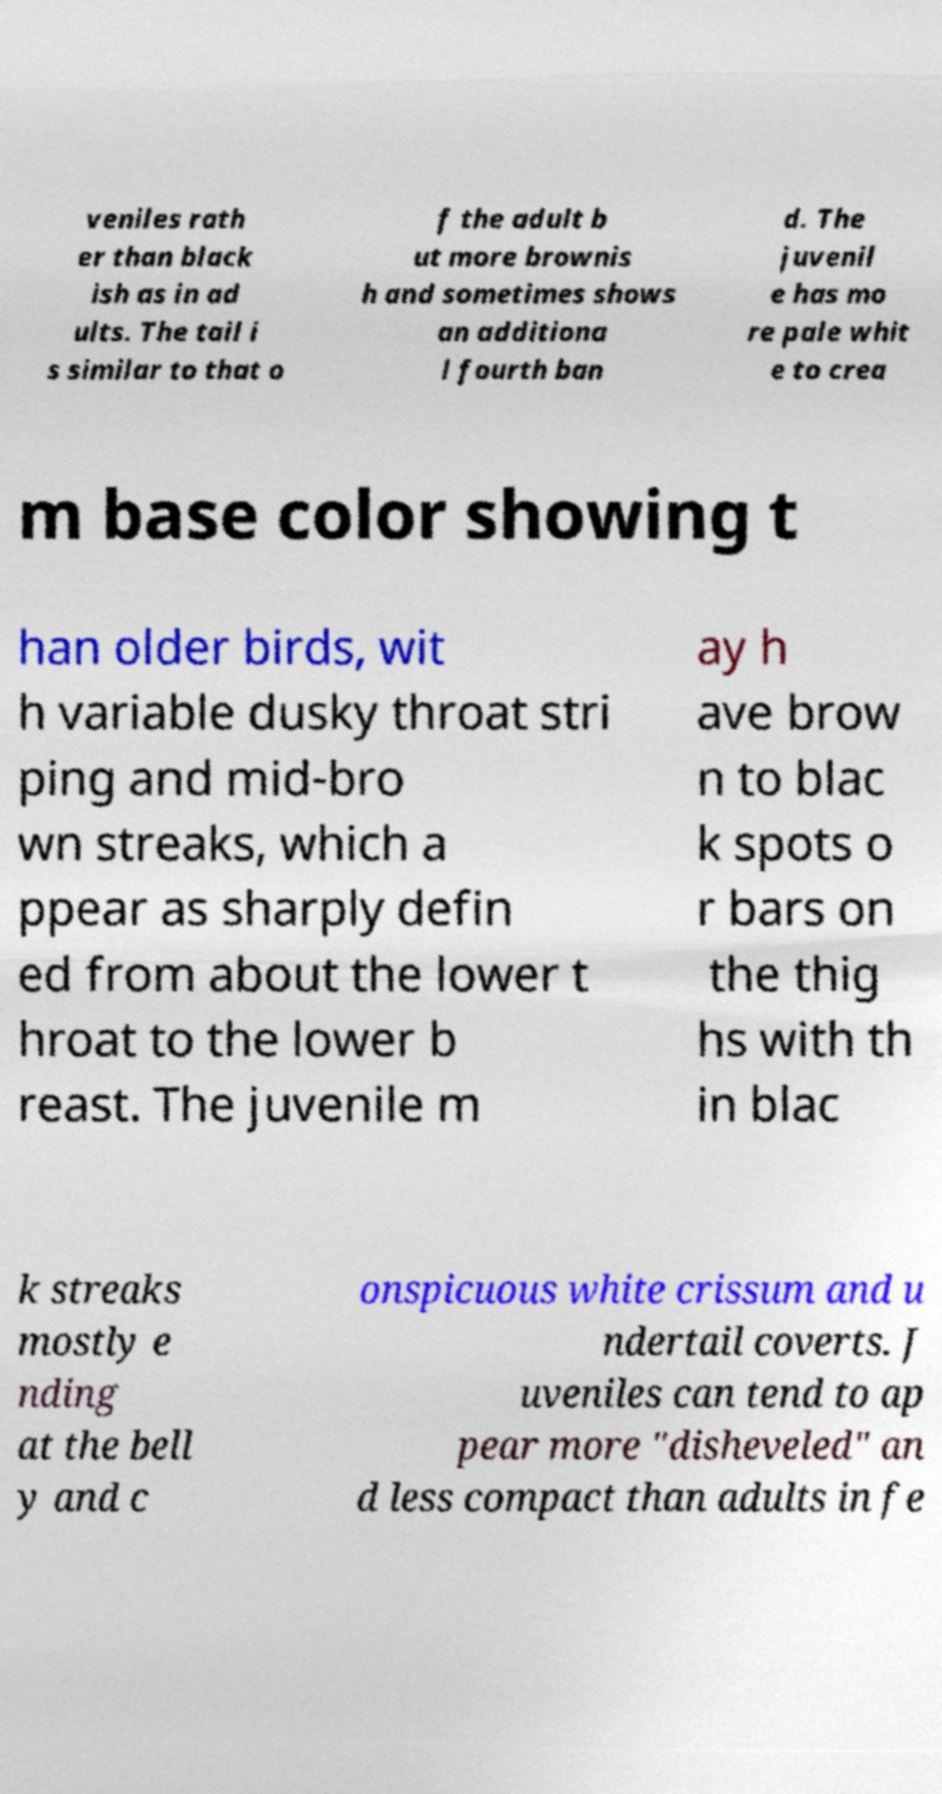Can you read and provide the text displayed in the image?This photo seems to have some interesting text. Can you extract and type it out for me? veniles rath er than black ish as in ad ults. The tail i s similar to that o f the adult b ut more brownis h and sometimes shows an additiona l fourth ban d. The juvenil e has mo re pale whit e to crea m base color showing t han older birds, wit h variable dusky throat stri ping and mid-bro wn streaks, which a ppear as sharply defin ed from about the lower t hroat to the lower b reast. The juvenile m ay h ave brow n to blac k spots o r bars on the thig hs with th in blac k streaks mostly e nding at the bell y and c onspicuous white crissum and u ndertail coverts. J uveniles can tend to ap pear more "disheveled" an d less compact than adults in fe 